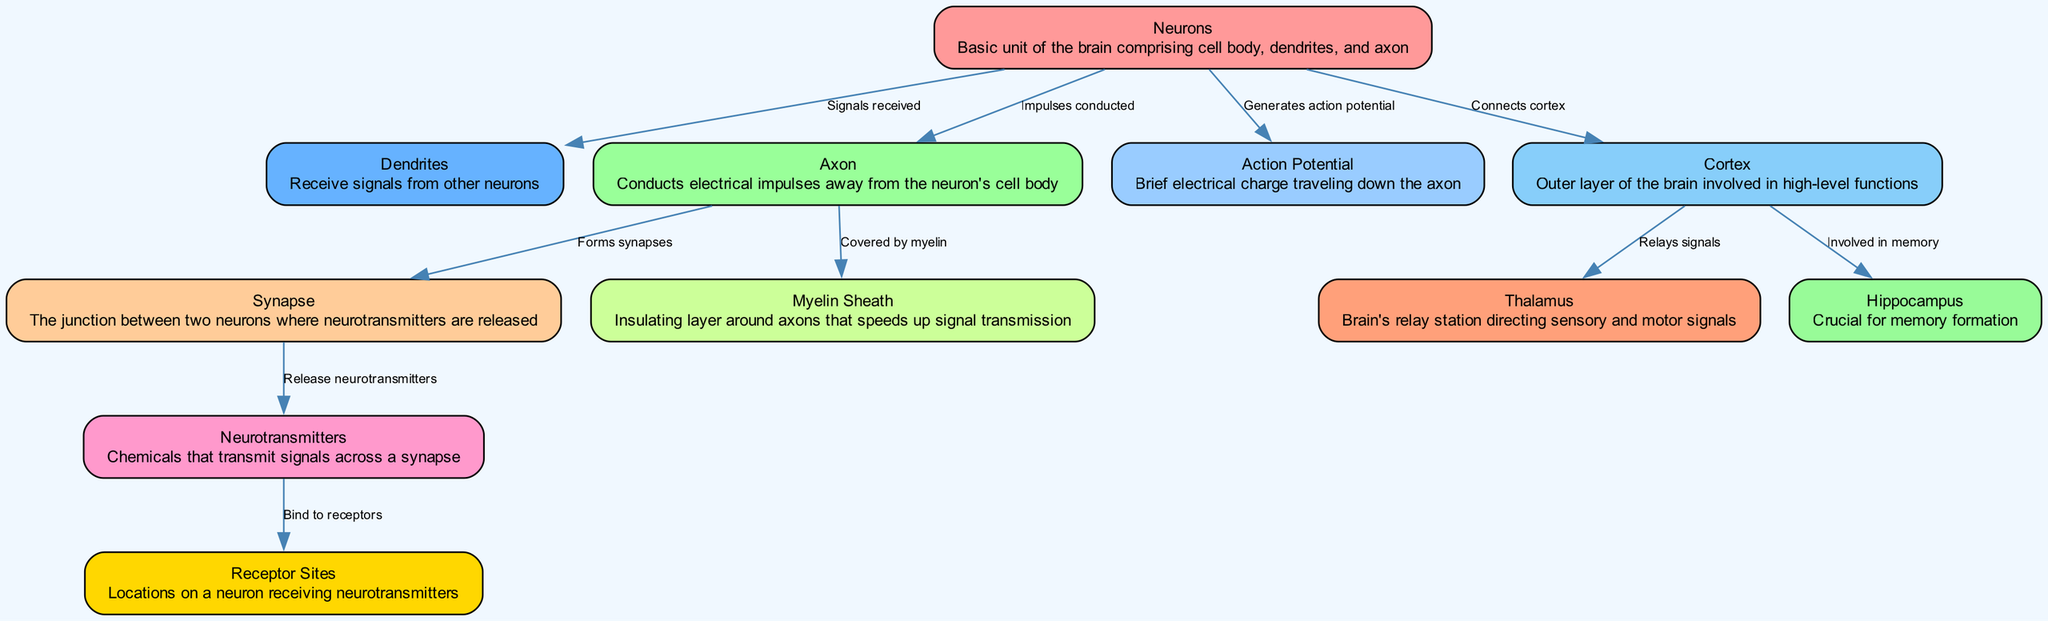What is the basic unit of the brain depicted here? The diagram shows "Neurons" as the basic unit of the brain. It is clearly labeled and described, making it easy to identify as foundational to brain function.
Answer: Neurons How many nodes are present in the diagram? By counting the individual elements listed in the nodes section of the data, there are ten unique elements presented.
Answer: 10 What connection is represented between Axon and Synapse? The diagram indicates that the Axon "Forms synapses" with labeled edges, specifically capturing the flow from the Axon to the Synapse.
Answer: Forms synapses Which structure is crucial for memory formation? The diagram highlights the "Hippocampus," labeling it specifically and indicating its role in memory processes within the brain.
Answer: Hippocampus What type of charge travels down the axon? The diagram describes the "Action Potential" as the brief electrical charge traveling down the axon, making it a key aspect of neuronal signaling.
Answer: Action Potential What do neurotransmitters bind to in the process depicted? According to the diagram, neurotransmitters specifically "Bind to receptors," as indicated by the labeled connection from neurotransmitters to receptor sites.
Answer: Receptor Sites Which structure is involved in high-level brain functions? The diagram identifies the "Cortex" as the outer layer of the brain, directly labeling it and associating it with complex functions in brain operations.
Answer: Cortex Which part of the brain acts as a relay station? The diagram specifies the "Thalamus" as the brain's relay station, making this function distinctly clear through its labeling and connection to other structures.
Answer: Thalamus What is the role of Myelin Sheath in neural pathways? In the diagram, the Myelin Sheath is described as providing an "Insulating layer" that speeds up signal transmission along the axon, which emphasizes its critical role.
Answer: Speeds up signal transmission 